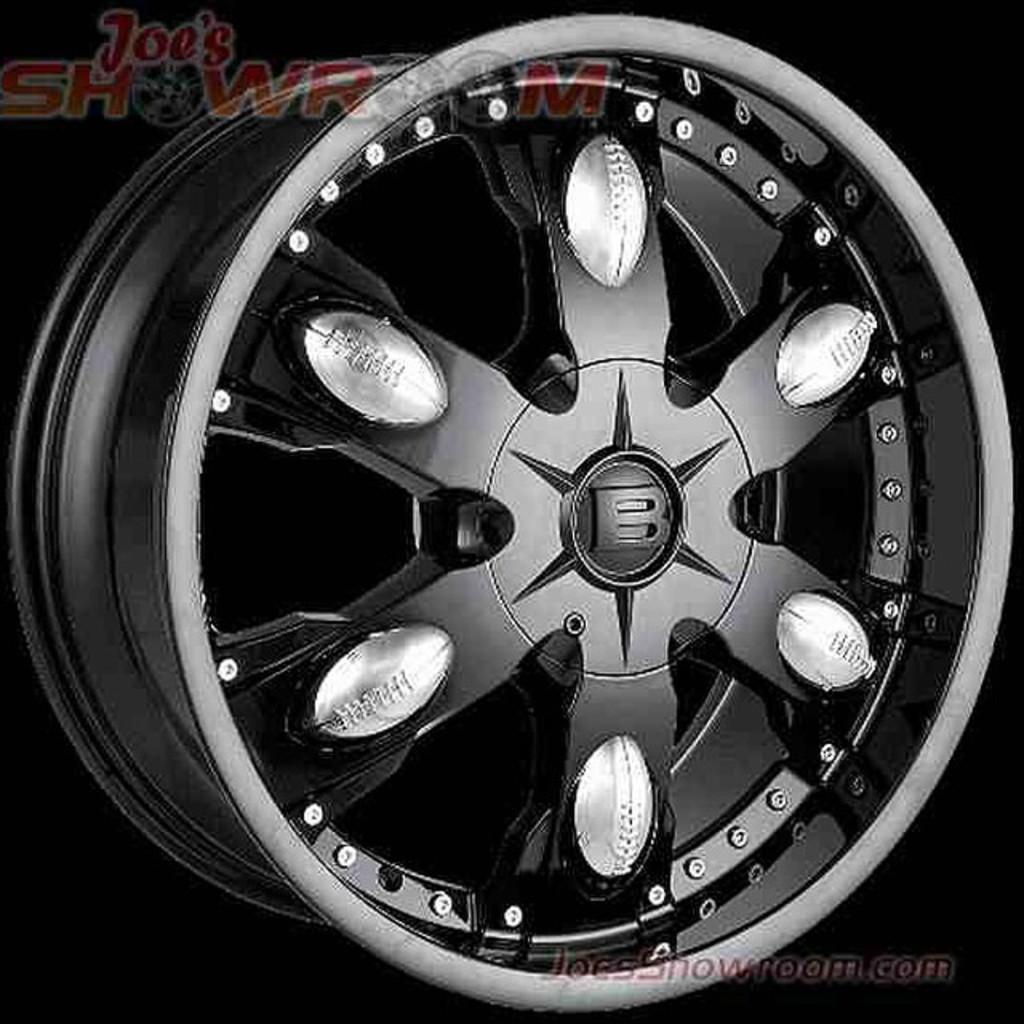What type of vehicle is in the image? There is a black car in the image. What part of the car is the focus of the image? The image shows a close view of the car's mac wheel. Can you describe the background of the image? The background of the image is dark. Is there a glove hanging from the car's rearview mirror in the image? There is no glove visible in the image, nor is there any mention of a rearview mirror. 